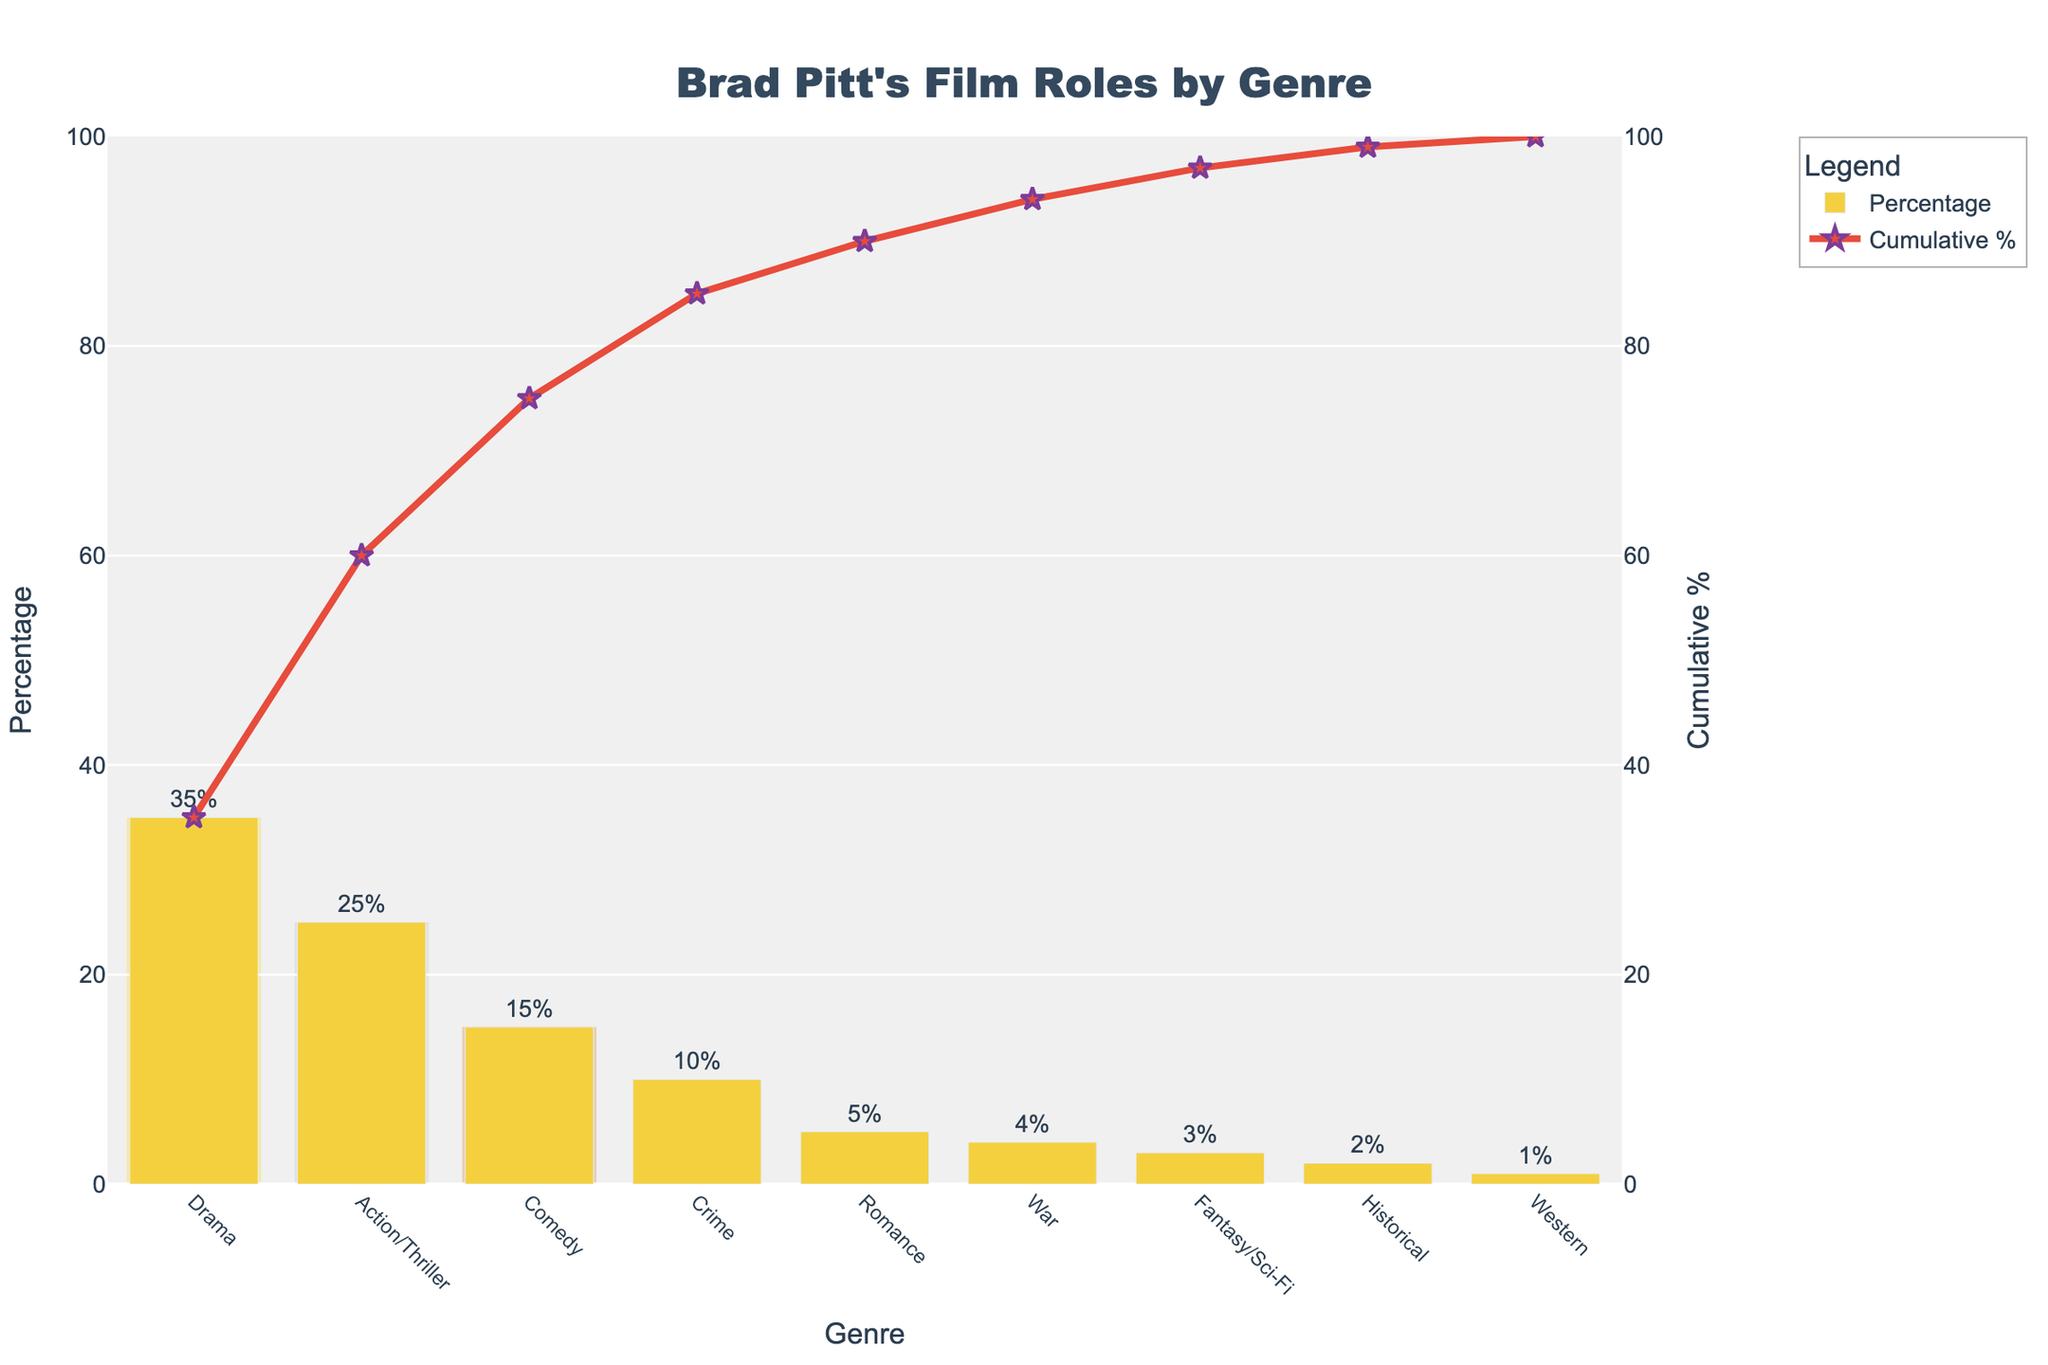What is the title of the chart? The title is centered at the top of the figure, and it describes what the chart is about.
Answer: Brad Pitt's Film Roles by Genre Which genre has the highest percentage of Brad Pitt's film roles? The genre with the highest bar represents the highest percentage of Brad Pitt's film roles, colored in yellow with the corresponding percentage marked.
Answer: Drama What is the cumulative percentage for Action/Thriller roles? Locate the Action/Thriller genre on the x-axis and follow it up to the red line representing cumulative percentage; read the value at that point.
Answer: 60% How many genres are represented in the chart? Count the distinct categories marked along the x-axis.
Answer: 9 Which genres have a percentage greater than 20%? Identify bars in the chart where the labeled percentage is greater than 20%.
Answer: Drama, Action/Thriller What is the difference in the percentage of roles between Comedy and Crime genres? Find the percentages for Comedy and Crime genres and subtract the Crime genre percentage from the Comedy genre percentage.
Answer: 5% Which genre reached above 50% cumulative percentage first? Check the cumulative percentage line to see which genre first makes the cumulative percentage surpass 50%.
Answer: Action/Thriller How do the percentages of Romance and Historical genres compare? Compare the heights of the bars labeled Romance and Historical, noting their percentages.
Answer: Romance is higher What genres are highlighted with colors other than yellow? Identify the bars with background highlighted in different colors and list their genres.
Answer: Drama, Action/Thriller, Comedy What percentage does the Western genre contribute to Brad Pitt's film roles? Look for the bar labeled Western on the x-axis and note its specific percentage.
Answer: 1% 